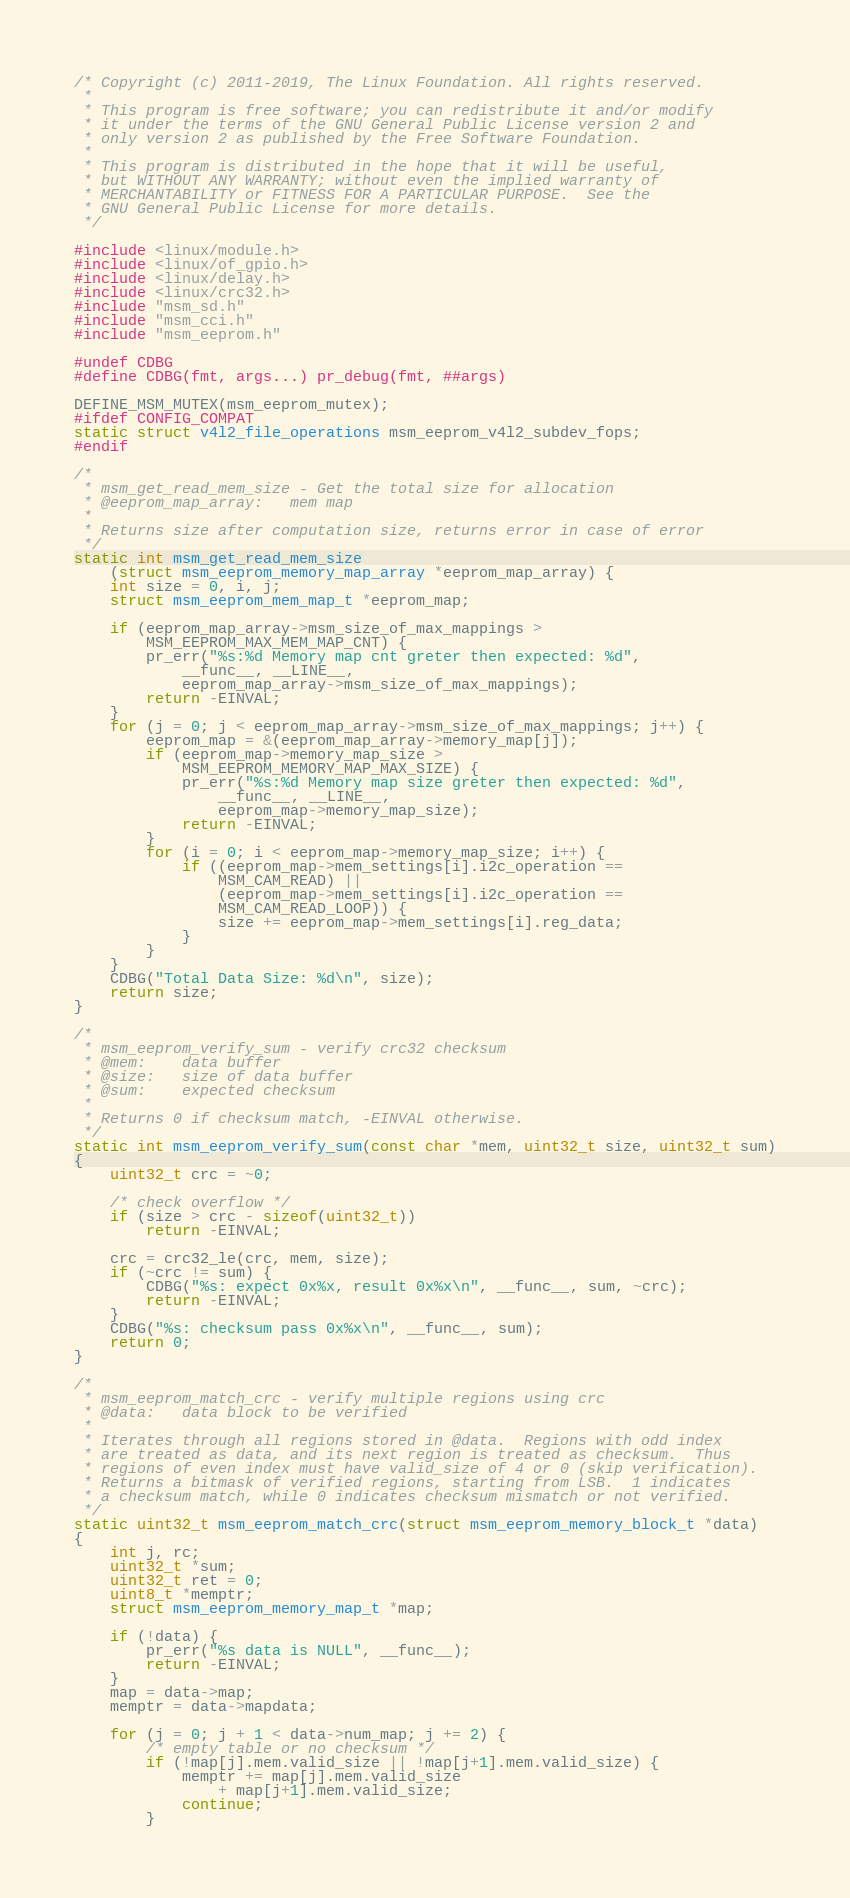<code> <loc_0><loc_0><loc_500><loc_500><_C_>/* Copyright (c) 2011-2019, The Linux Foundation. All rights reserved.
 *
 * This program is free software; you can redistribute it and/or modify
 * it under the terms of the GNU General Public License version 2 and
 * only version 2 as published by the Free Software Foundation.
 *
 * This program is distributed in the hope that it will be useful,
 * but WITHOUT ANY WARRANTY; without even the implied warranty of
 * MERCHANTABILITY or FITNESS FOR A PARTICULAR PURPOSE.  See the
 * GNU General Public License for more details.
 */

#include <linux/module.h>
#include <linux/of_gpio.h>
#include <linux/delay.h>
#include <linux/crc32.h>
#include "msm_sd.h"
#include "msm_cci.h"
#include "msm_eeprom.h"

#undef CDBG
#define CDBG(fmt, args...) pr_debug(fmt, ##args)

DEFINE_MSM_MUTEX(msm_eeprom_mutex);
#ifdef CONFIG_COMPAT
static struct v4l2_file_operations msm_eeprom_v4l2_subdev_fops;
#endif

/*
 * msm_get_read_mem_size - Get the total size for allocation
 * @eeprom_map_array:	mem map
 *
 * Returns size after computation size, returns error in case of error
 */
static int msm_get_read_mem_size
	(struct msm_eeprom_memory_map_array *eeprom_map_array) {
	int size = 0, i, j;
	struct msm_eeprom_mem_map_t *eeprom_map;

	if (eeprom_map_array->msm_size_of_max_mappings >
		MSM_EEPROM_MAX_MEM_MAP_CNT) {
		pr_err("%s:%d Memory map cnt greter then expected: %d",
			__func__, __LINE__,
			eeprom_map_array->msm_size_of_max_mappings);
		return -EINVAL;
	}
	for (j = 0; j < eeprom_map_array->msm_size_of_max_mappings; j++) {
		eeprom_map = &(eeprom_map_array->memory_map[j]);
		if (eeprom_map->memory_map_size >
			MSM_EEPROM_MEMORY_MAP_MAX_SIZE) {
			pr_err("%s:%d Memory map size greter then expected: %d",
				__func__, __LINE__,
				eeprom_map->memory_map_size);
			return -EINVAL;
		}
		for (i = 0; i < eeprom_map->memory_map_size; i++) {
			if ((eeprom_map->mem_settings[i].i2c_operation ==
				MSM_CAM_READ) ||
				(eeprom_map->mem_settings[i].i2c_operation ==
				MSM_CAM_READ_LOOP)) {
				size += eeprom_map->mem_settings[i].reg_data;
			}
		}
	}
	CDBG("Total Data Size: %d\n", size);
	return size;
}

/*
 * msm_eeprom_verify_sum - verify crc32 checksum
 * @mem:	data buffer
 * @size:	size of data buffer
 * @sum:	expected checksum
 *
 * Returns 0 if checksum match, -EINVAL otherwise.
 */
static int msm_eeprom_verify_sum(const char *mem, uint32_t size, uint32_t sum)
{
	uint32_t crc = ~0;

	/* check overflow */
	if (size > crc - sizeof(uint32_t))
		return -EINVAL;

	crc = crc32_le(crc, mem, size);
	if (~crc != sum) {
		CDBG("%s: expect 0x%x, result 0x%x\n", __func__, sum, ~crc);
		return -EINVAL;
	}
	CDBG("%s: checksum pass 0x%x\n", __func__, sum);
	return 0;
}

/*
 * msm_eeprom_match_crc - verify multiple regions using crc
 * @data:	data block to be verified
 *
 * Iterates through all regions stored in @data.  Regions with odd index
 * are treated as data, and its next region is treated as checksum.  Thus
 * regions of even index must have valid_size of 4 or 0 (skip verification).
 * Returns a bitmask of verified regions, starting from LSB.  1 indicates
 * a checksum match, while 0 indicates checksum mismatch or not verified.
 */
static uint32_t msm_eeprom_match_crc(struct msm_eeprom_memory_block_t *data)
{
	int j, rc;
	uint32_t *sum;
	uint32_t ret = 0;
	uint8_t *memptr;
	struct msm_eeprom_memory_map_t *map;

	if (!data) {
		pr_err("%s data is NULL", __func__);
		return -EINVAL;
	}
	map = data->map;
	memptr = data->mapdata;

	for (j = 0; j + 1 < data->num_map; j += 2) {
		/* empty table or no checksum */
		if (!map[j].mem.valid_size || !map[j+1].mem.valid_size) {
			memptr += map[j].mem.valid_size
				+ map[j+1].mem.valid_size;
			continue;
		}</code> 